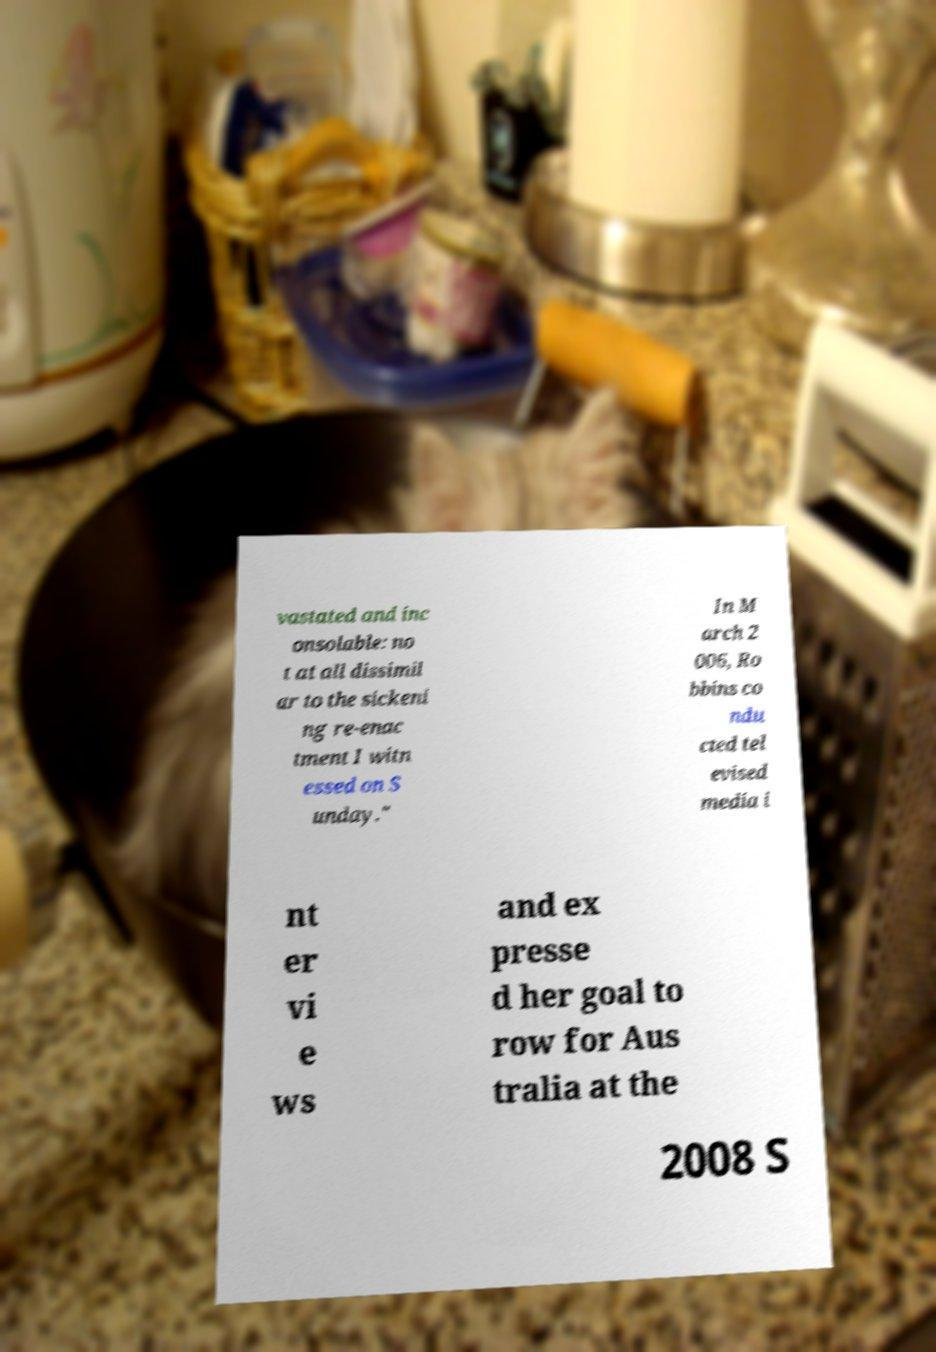I need the written content from this picture converted into text. Can you do that? vastated and inc onsolable: no t at all dissimil ar to the sickeni ng re-enac tment I witn essed on S unday." In M arch 2 006, Ro bbins co ndu cted tel evised media i nt er vi e ws and ex presse d her goal to row for Aus tralia at the 2008 S 